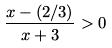<formula> <loc_0><loc_0><loc_500><loc_500>\frac { x - ( 2 / 3 ) } { x + 3 } > 0</formula> 